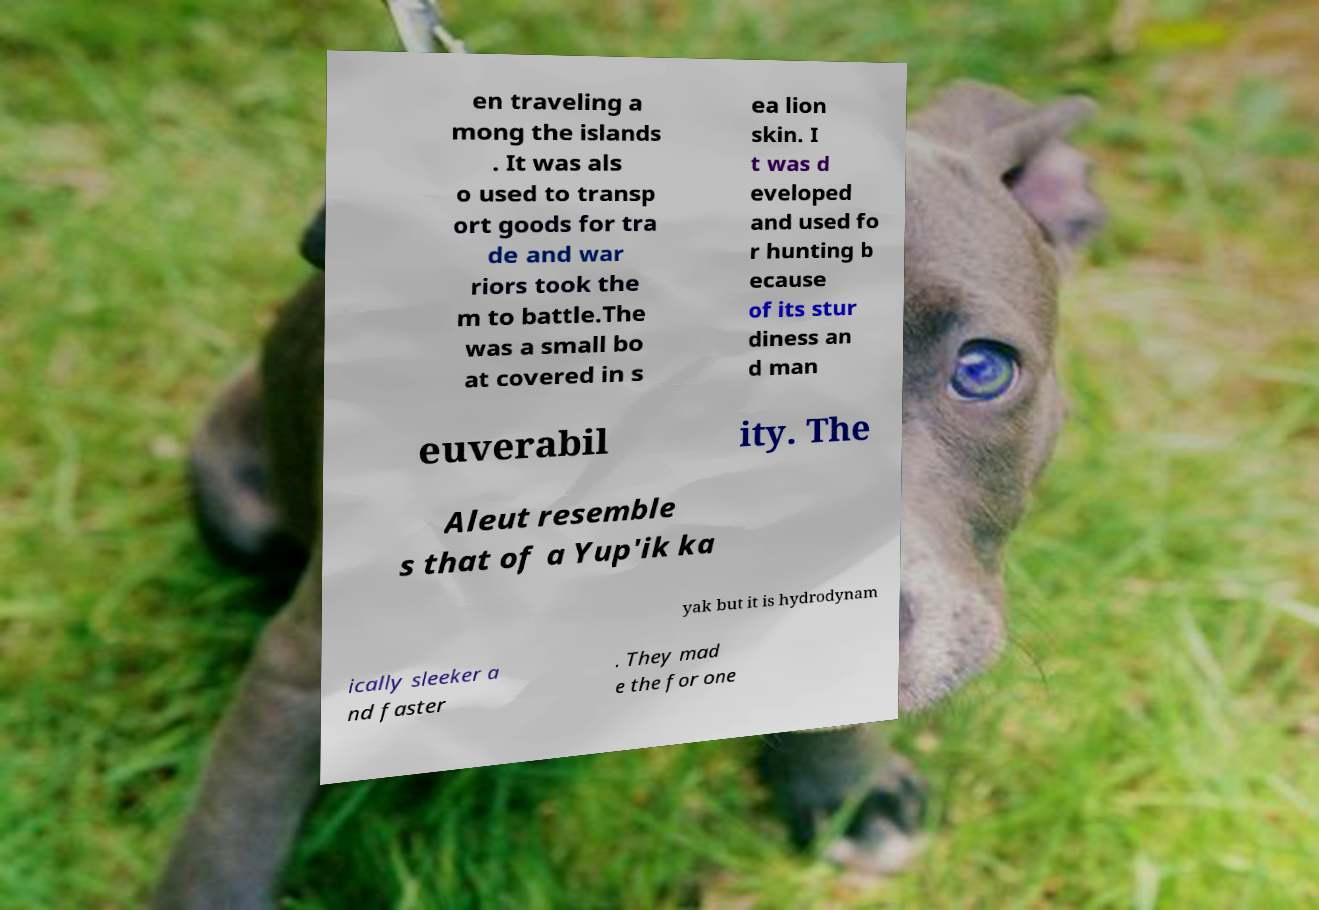Please identify and transcribe the text found in this image. en traveling a mong the islands . It was als o used to transp ort goods for tra de and war riors took the m to battle.The was a small bo at covered in s ea lion skin. I t was d eveloped and used fo r hunting b ecause of its stur diness an d man euverabil ity. The Aleut resemble s that of a Yup'ik ka yak but it is hydrodynam ically sleeker a nd faster . They mad e the for one 